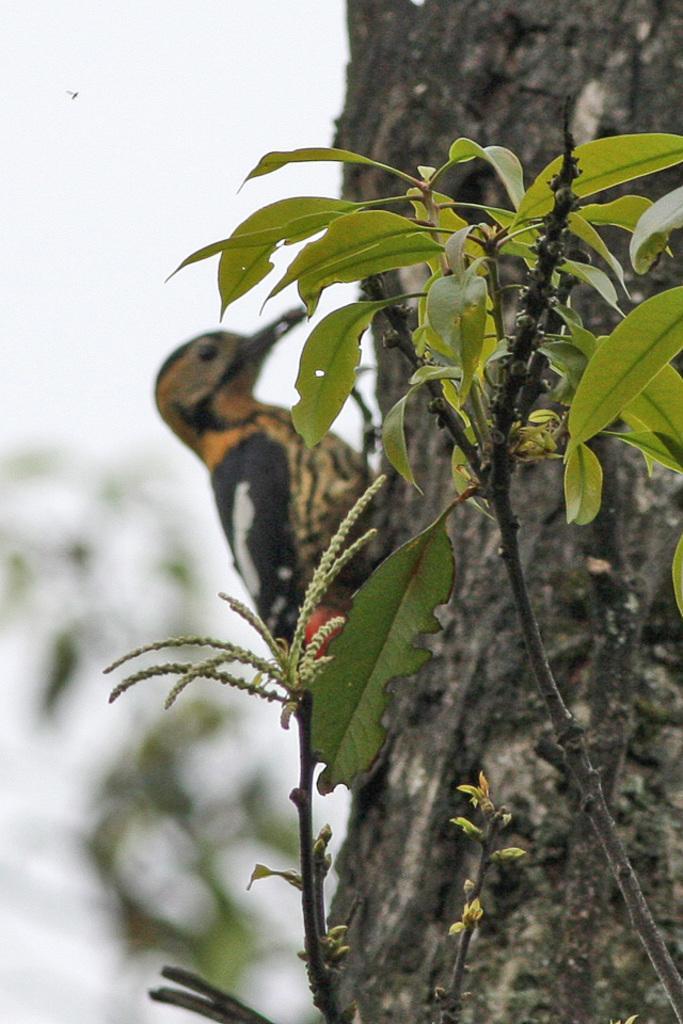How would you summarize this image in a sentence or two? In this image I can see a bird which is in black and brown color on the tree, in front I can see a plant in green color. Background the sky is in white color. 